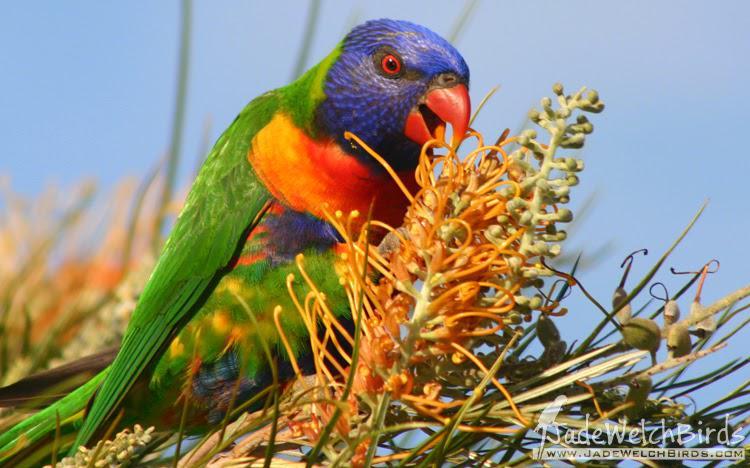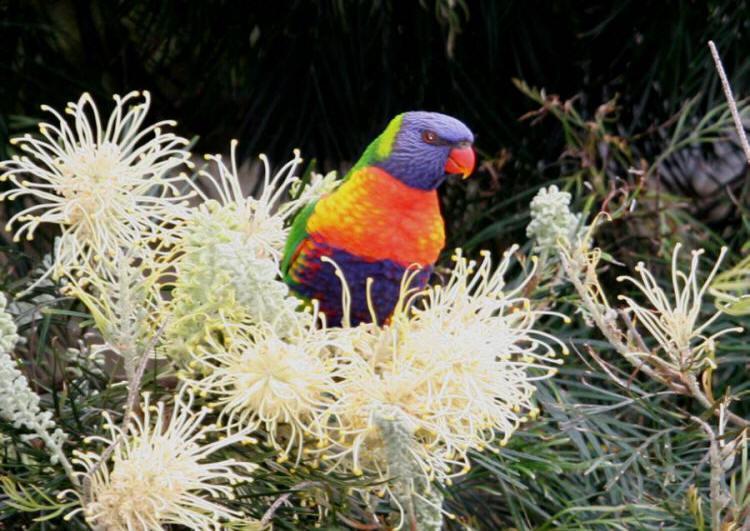The first image is the image on the left, the second image is the image on the right. For the images shown, is this caption "An image shows exactly one parrot perched among branches of red flowers with tendril petals." true? Answer yes or no. No. The first image is the image on the left, the second image is the image on the right. Given the left and right images, does the statement "Two birds are facing the same direction." hold true? Answer yes or no. Yes. 